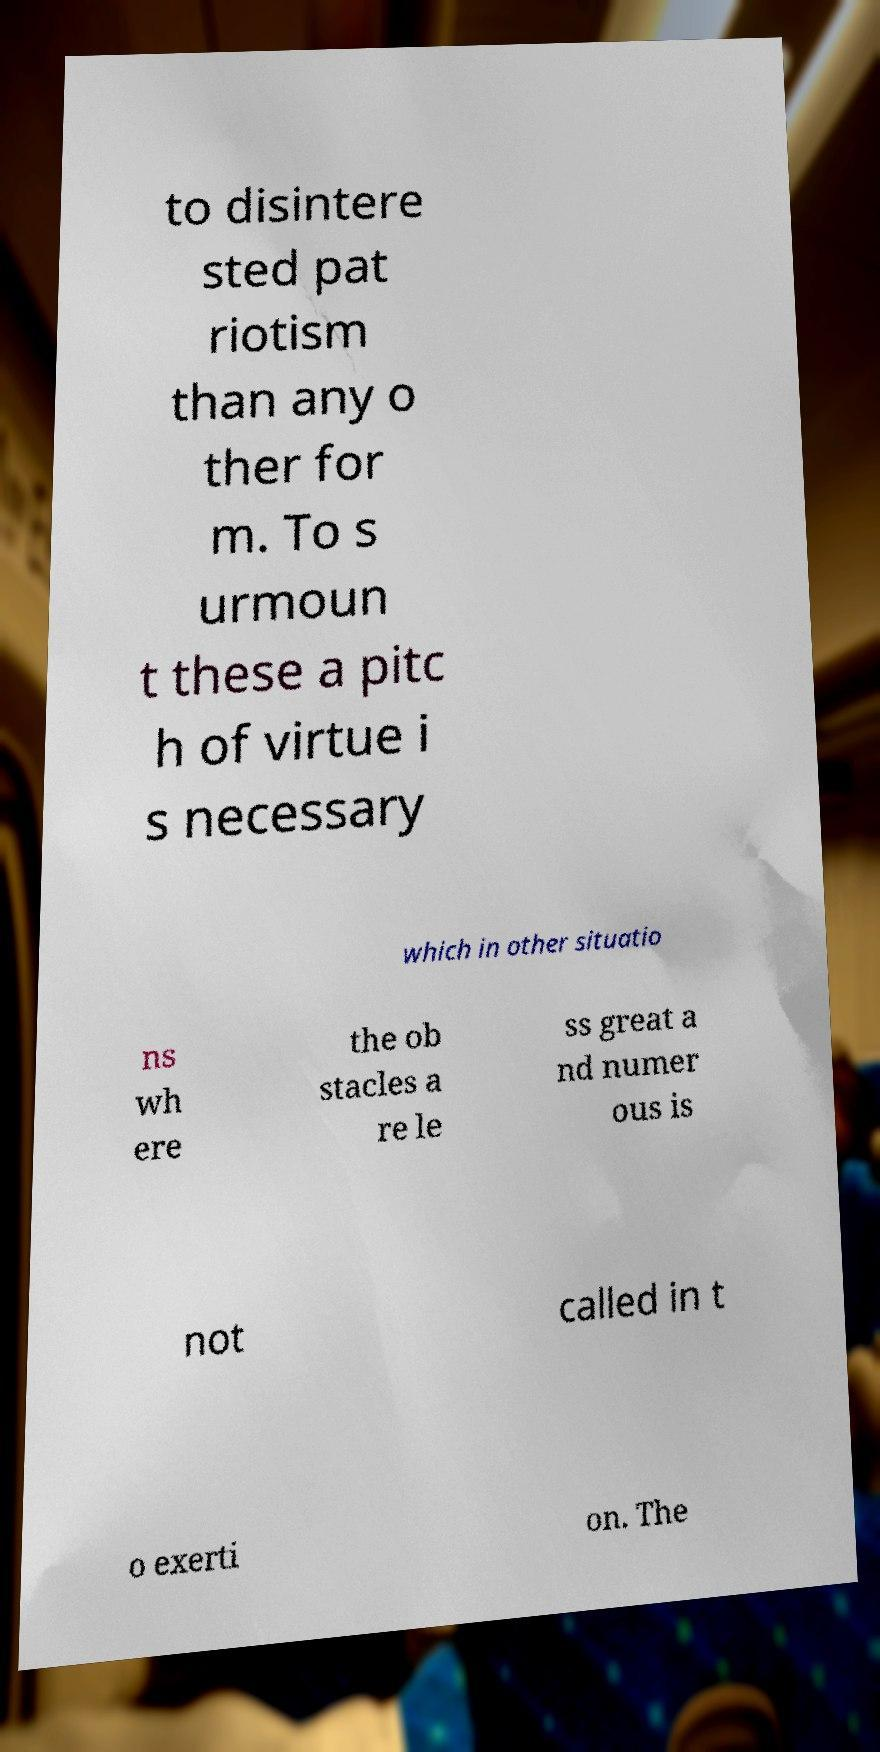There's text embedded in this image that I need extracted. Can you transcribe it verbatim? to disintere sted pat riotism than any o ther for m. To s urmoun t these a pitc h of virtue i s necessary which in other situatio ns wh ere the ob stacles a re le ss great a nd numer ous is not called in t o exerti on. The 